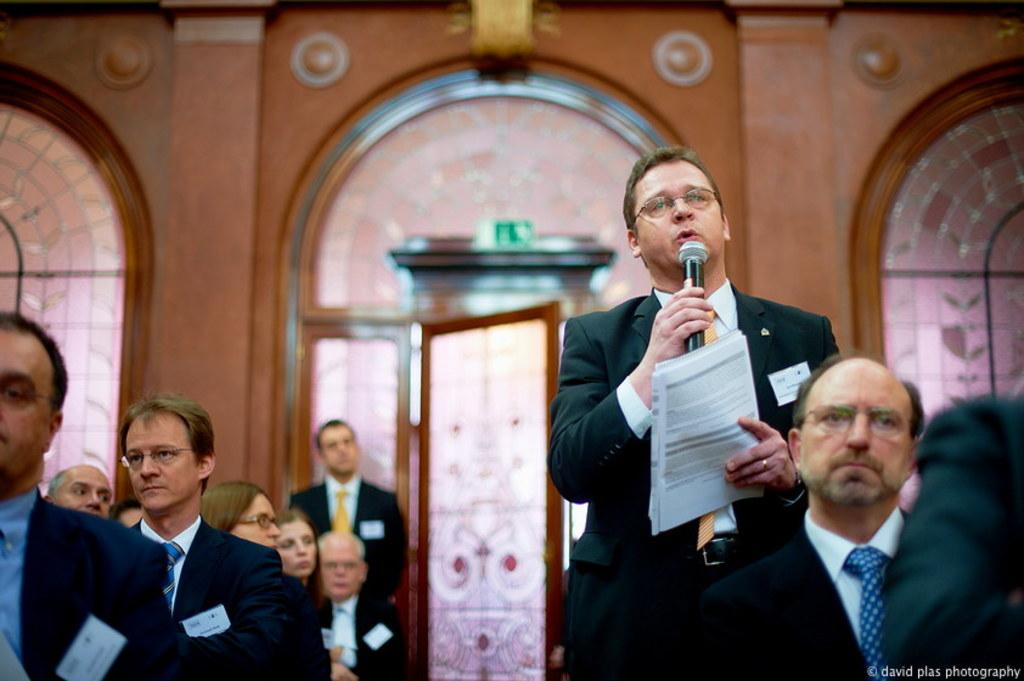What is the man in the image doing? The man is talking on a microphone. What is the man holding in his hand? The man is holding papers in his hand. What can be seen on the man's face? The man is wearing spectacles. What is visible in the background of the image? There is a wall and a door in the background of the image. How many people are present in the image? There are other people in the image besides the man. What type of plastic material can be seen in the image? There is no plastic material present in the image. Can you see a gate in the image? There is no gate present in the image; only a wall and a door are visible in the background. 